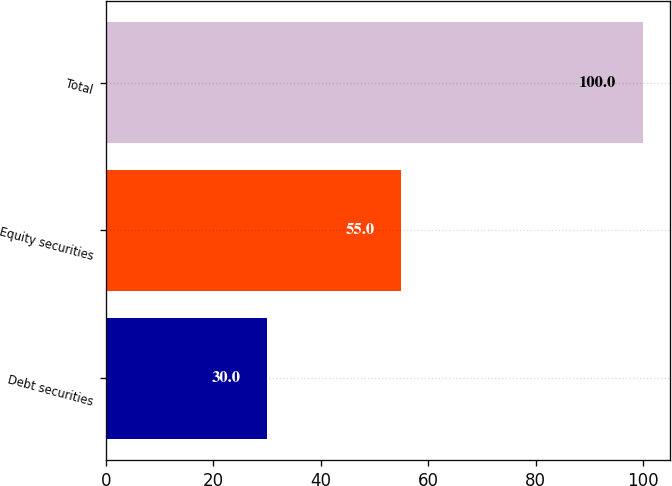Convert chart. <chart><loc_0><loc_0><loc_500><loc_500><bar_chart><fcel>Debt securities<fcel>Equity securities<fcel>Total<nl><fcel>30<fcel>55<fcel>100<nl></chart> 